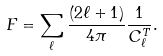Convert formula to latex. <formula><loc_0><loc_0><loc_500><loc_500>F = \sum _ { \ell } \frac { ( 2 \ell + 1 ) } { 4 \pi } \frac { 1 } { C ^ { T } _ { \ell } } .</formula> 